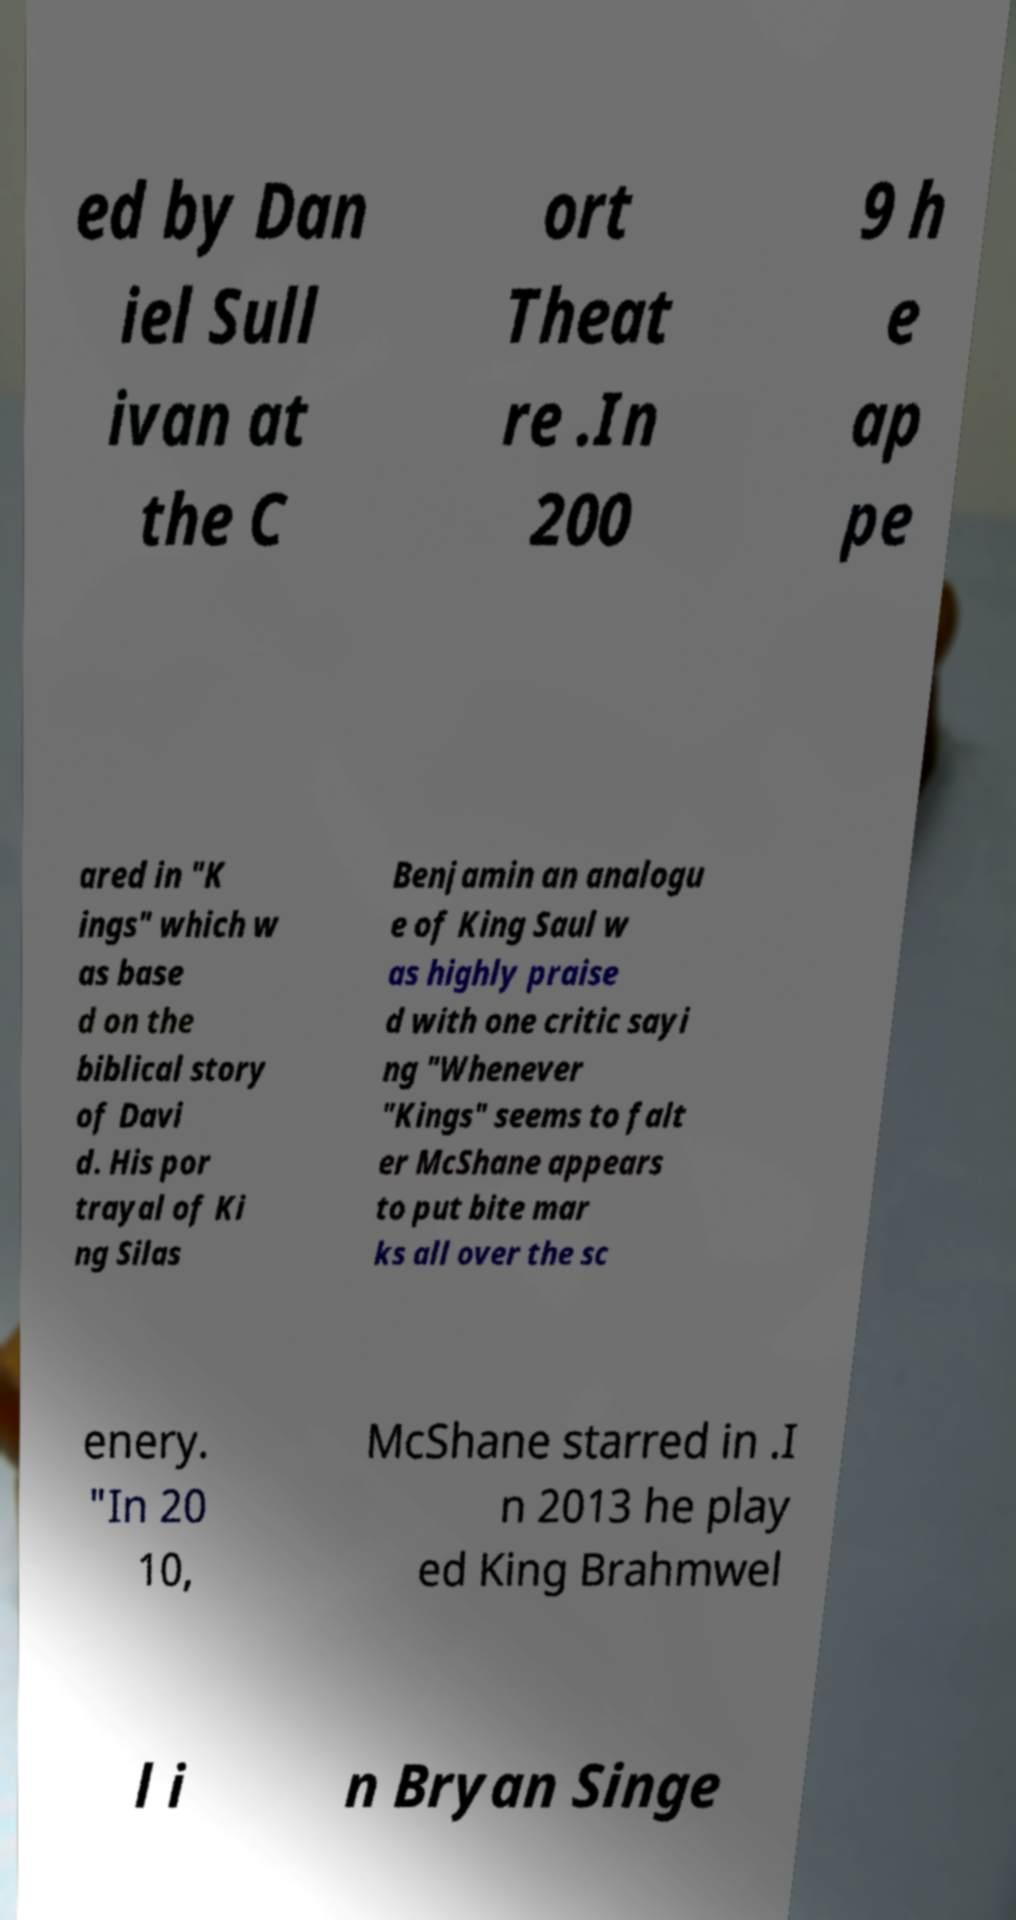There's text embedded in this image that I need extracted. Can you transcribe it verbatim? ed by Dan iel Sull ivan at the C ort Theat re .In 200 9 h e ap pe ared in "K ings" which w as base d on the biblical story of Davi d. His por trayal of Ki ng Silas Benjamin an analogu e of King Saul w as highly praise d with one critic sayi ng "Whenever "Kings" seems to falt er McShane appears to put bite mar ks all over the sc enery. "In 20 10, McShane starred in .I n 2013 he play ed King Brahmwel l i n Bryan Singe 